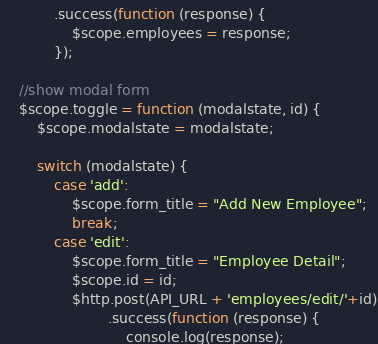Convert code to text. <code><loc_0><loc_0><loc_500><loc_500><_JavaScript_>            .success(function (response) {
                $scope.employees = response;
            });

    //show modal form
    $scope.toggle = function (modalstate, id) {
        $scope.modalstate = modalstate;

        switch (modalstate) {
            case 'add':
                $scope.form_title = "Add New Employee";
                break;
            case 'edit':
                $scope.form_title = "Employee Detail";
                $scope.id = id;
                $http.post(API_URL + 'employees/edit/'+id)
                        .success(function (response) {
                            console.log(response);</code> 